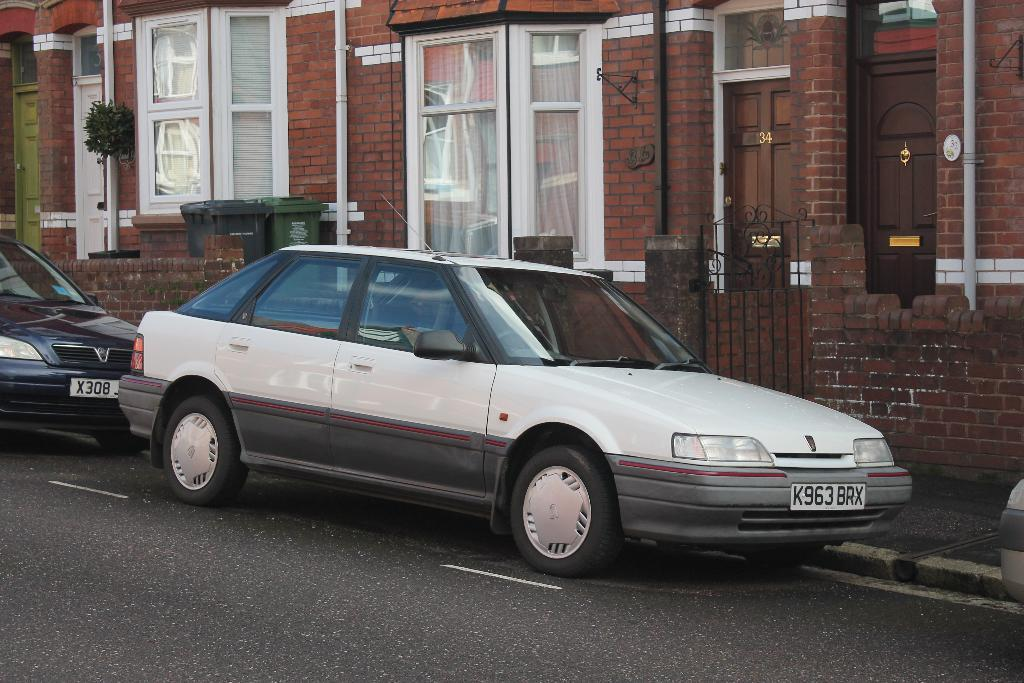What can be seen on the road in the image? There is a group of vehicles parked on the road. What is visible in the background of the image? There is a building and a plant in the background of the image. Is there any indication of waste management in the image? Yes, there is a trash bin in the background of the image. Can you describe the air quality in the image? The provided facts do not give any information about the air quality in the image. --- Facts: 1. There is a person holding a book in the image. 2. The person is sitting on a chair. 3. There is a table in front of the person. 4. The book has a red cover. 5. The chair has a cushion. Absurd Topics: dance, ocean, parrot Conversation: What is the person in the image holding? The person in the image is holding a book. What is the person's posture in the image? The person is sitting on a chair. What is in front of the person? There is a table in front of the person. What is the color of the book cover? The book cover is red. What is the chair like? The chair has a cushion. Reasoning: Let's think step by step in order to produce the conversation. We start by identifying the main subject in the image, which is the person holding a book. Then, we expand the conversation to include the person's posture, the presence of a table, the color of the book cover, and the characteristics of the chair. Each question is designed to elicit a specific detail about the image that is known from the provided facts. Absurd Question/Answer: Can you describe the parrot sitting on the person's shoulder in the image? There is no parrot present in the image. 